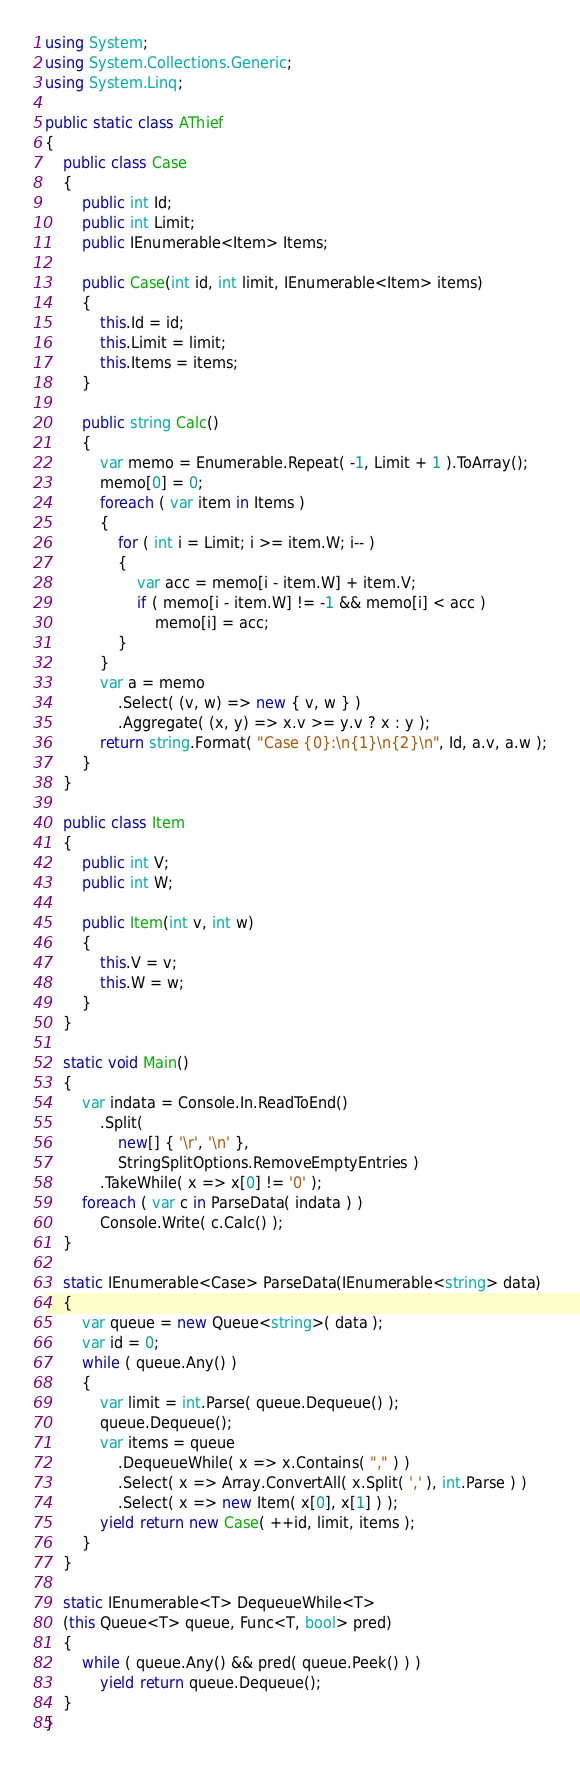<code> <loc_0><loc_0><loc_500><loc_500><_C#_>using System;
using System.Collections.Generic;
using System.Linq;

public static class AThief
{
    public class Case
    {
        public int Id;
        public int Limit;
        public IEnumerable<Item> Items;

        public Case(int id, int limit, IEnumerable<Item> items)
        {
            this.Id = id;
            this.Limit = limit;
            this.Items = items;
        }

        public string Calc()
        {
            var memo = Enumerable.Repeat( -1, Limit + 1 ).ToArray();
            memo[0] = 0;
            foreach ( var item in Items )
            {
                for ( int i = Limit; i >= item.W; i-- )
                {
                    var acc = memo[i - item.W] + item.V;
                    if ( memo[i - item.W] != -1 && memo[i] < acc )
                        memo[i] = acc;
                }
            }
            var a = memo
                .Select( (v, w) => new { v, w } )
                .Aggregate( (x, y) => x.v >= y.v ? x : y );
            return string.Format( "Case {0}:\n{1}\n{2}\n", Id, a.v, a.w );
        }
    }

    public class Item
    {
        public int V;
        public int W;

        public Item(int v, int w)
        {
            this.V = v;
            this.W = w;
        }
    }

    static void Main()
    {
        var indata = Console.In.ReadToEnd()
            .Split( 
                new[] { '\r', '\n' },
                StringSplitOptions.RemoveEmptyEntries )
            .TakeWhile( x => x[0] != '0' );
        foreach ( var c in ParseData( indata ) )
            Console.Write( c.Calc() );
    }

    static IEnumerable<Case> ParseData(IEnumerable<string> data)
    {
        var queue = new Queue<string>( data );
        var id = 0;
        while ( queue.Any() )
        {
            var limit = int.Parse( queue.Dequeue() );
            queue.Dequeue();
            var items = queue
                .DequeueWhile( x => x.Contains( "," ) )
                .Select( x => Array.ConvertAll( x.Split( ',' ), int.Parse ) )
                .Select( x => new Item( x[0], x[1] ) );
            yield return new Case( ++id, limit, items );
        }
    }

    static IEnumerable<T> DequeueWhile<T>
    (this Queue<T> queue, Func<T, bool> pred)
    {
        while ( queue.Any() && pred( queue.Peek() ) )
            yield return queue.Dequeue();
    }
}</code> 